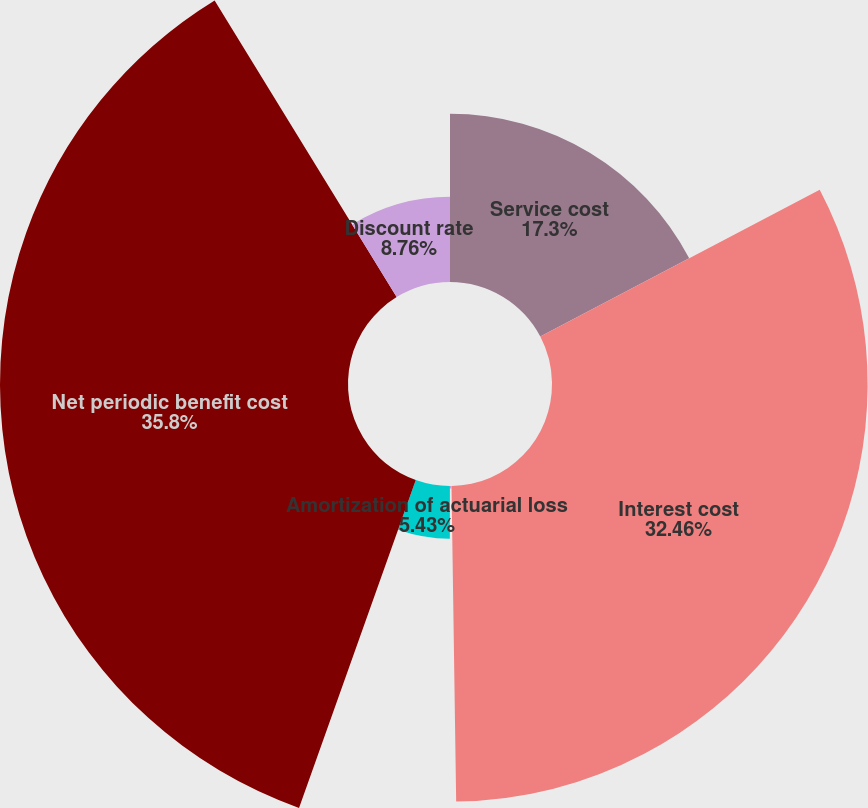<chart> <loc_0><loc_0><loc_500><loc_500><pie_chart><fcel>Service cost<fcel>Interest cost<fcel>Amortization of<fcel>Amortization of actuarial loss<fcel>Net periodic benefit cost<fcel>Discount rate<nl><fcel>17.3%<fcel>32.46%<fcel>0.25%<fcel>5.43%<fcel>35.79%<fcel>8.76%<nl></chart> 